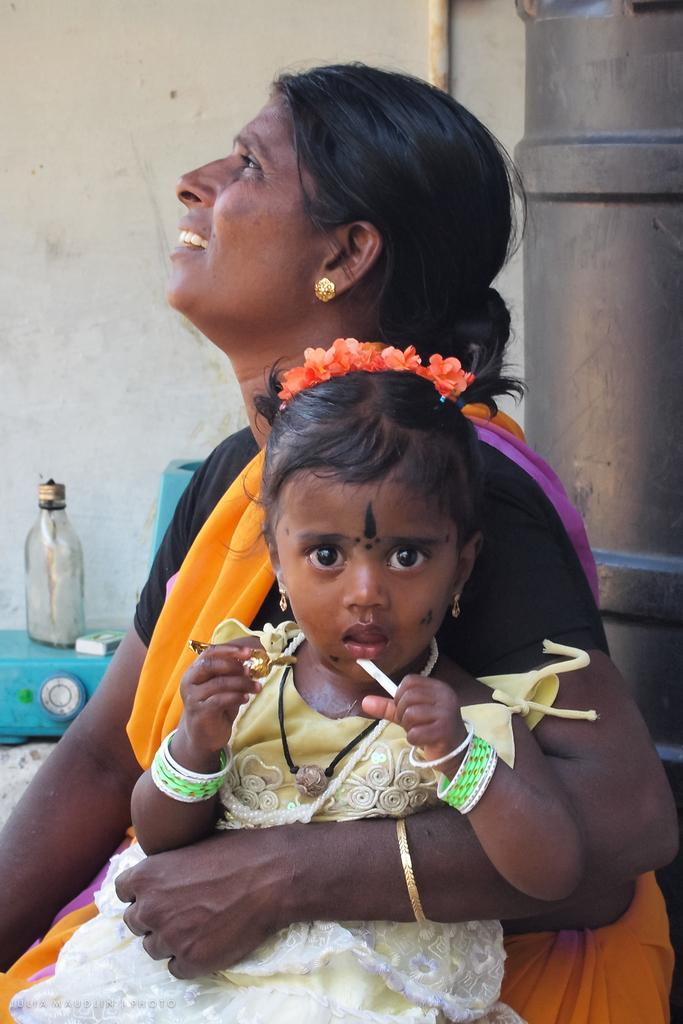Who is the main subject in the image? There is a woman in the center of the image. What is the woman holding in the image? The woman is holding a baby. What objects can be seen on the left side of the image? There is a glass bottle and a matchbox on the left side of the image. What type of flag is visible in the image? There is no flag present in the image. How much money is the woman holding in the image? The woman is not holding any money in the image; she is holding a baby. 